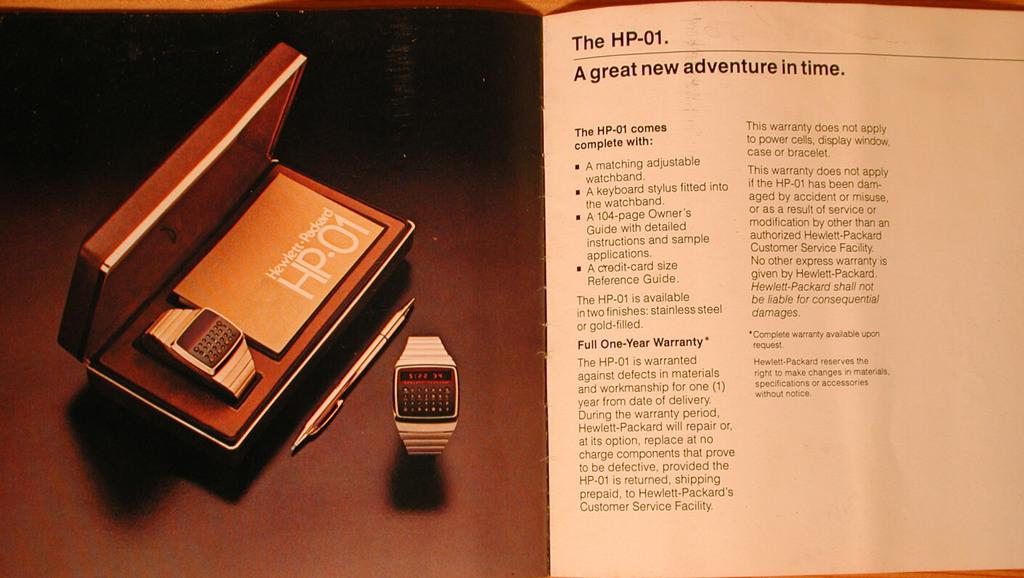What kind of adventure do they say this product is?
Give a very brief answer. Adventure in time. What is the name of the watch?
Offer a very short reply. Hp-01. 